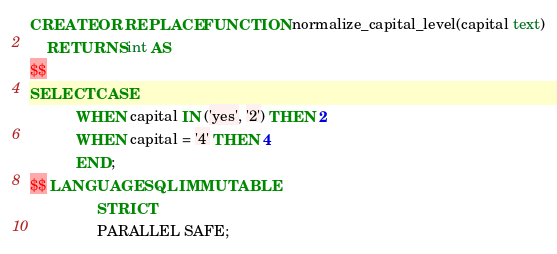Convert code to text. <code><loc_0><loc_0><loc_500><loc_500><_SQL_>CREATE OR REPLACE FUNCTION normalize_capital_level(capital text)
    RETURNS int AS
$$
SELECT CASE
           WHEN capital IN ('yes', '2') THEN 2
           WHEN capital = '4' THEN 4
           END;
$$ LANGUAGE SQL IMMUTABLE
                STRICT
                PARALLEL SAFE;
</code> 